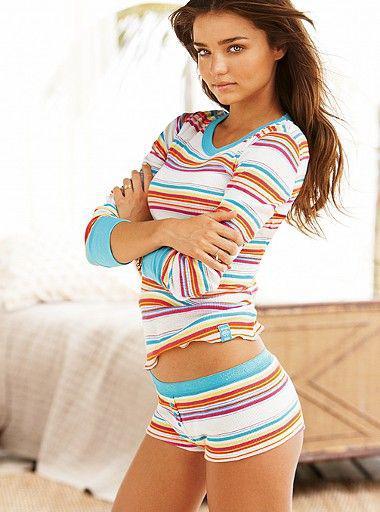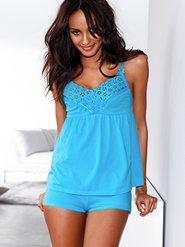The first image is the image on the left, the second image is the image on the right. Considering the images on both sides, is "A model wears a long-sleeved robe-type cover-up over intimate apparel in one image." valid? Answer yes or no. No. The first image is the image on the left, the second image is the image on the right. Considering the images on both sides, is "One solid color pajama set has a top with straps and lacy bra area, as well as a very short matching bottom." valid? Answer yes or no. Yes. 